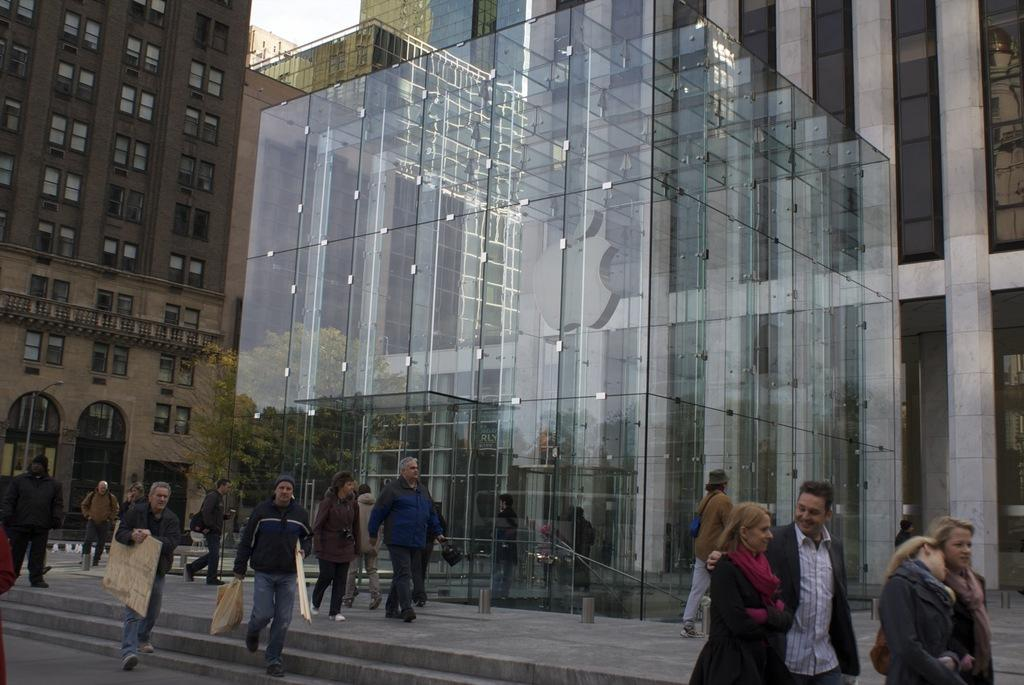What type of structures are present in the image? There are buildings in the image. What feature do the buildings have? The buildings have windows. What is happening at the bottom of the image? There are people walking at the bottom of the image. What material are the buildings made of? The buildings are made up of glass. How many fingers can be seen on the cow in the image? There is no cow present in the image, so it is not possible to determine the number of fingers on a cow. 